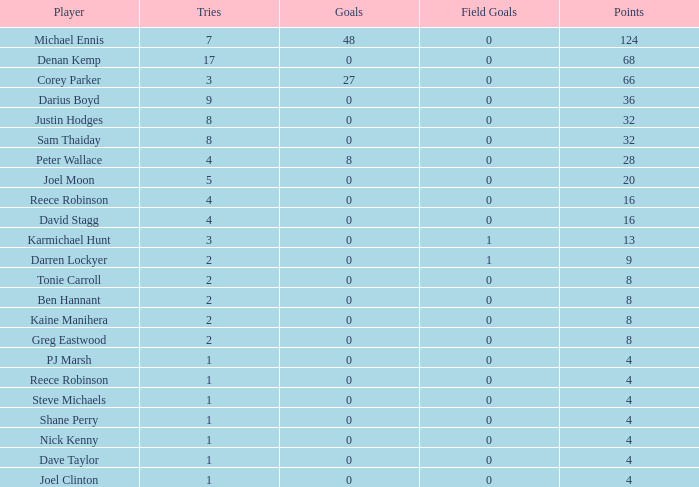What was the number of goals scored by the player who had fewer than 4 points? 0.0. 